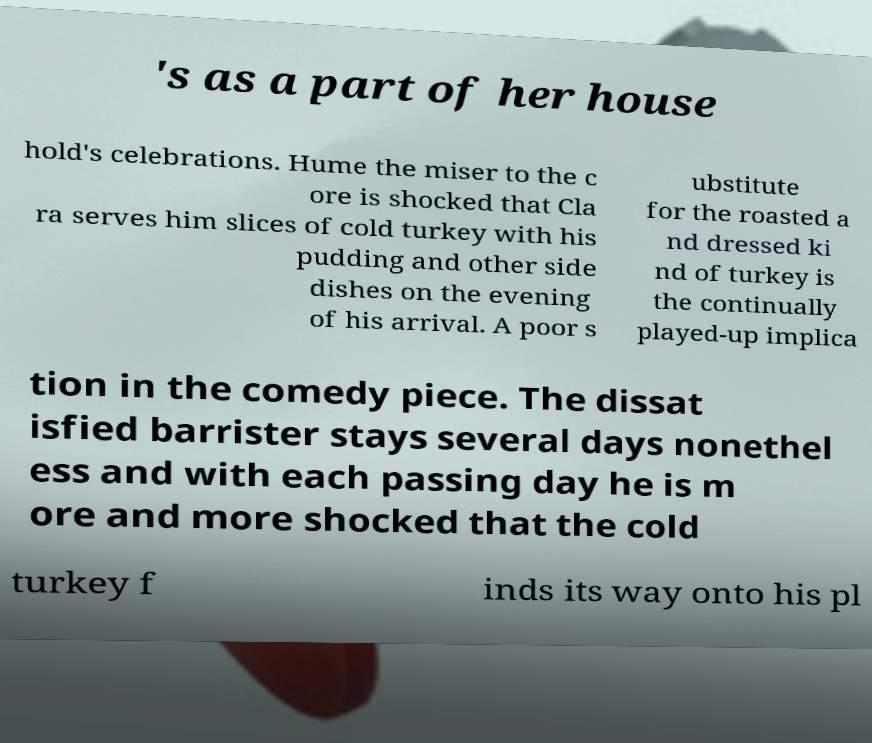Could you assist in decoding the text presented in this image and type it out clearly? 's as a part of her house hold's celebrations. Hume the miser to the c ore is shocked that Cla ra serves him slices of cold turkey with his pudding and other side dishes on the evening of his arrival. A poor s ubstitute for the roasted a nd dressed ki nd of turkey is the continually played-up implica tion in the comedy piece. The dissat isfied barrister stays several days nonethel ess and with each passing day he is m ore and more shocked that the cold turkey f inds its way onto his pl 